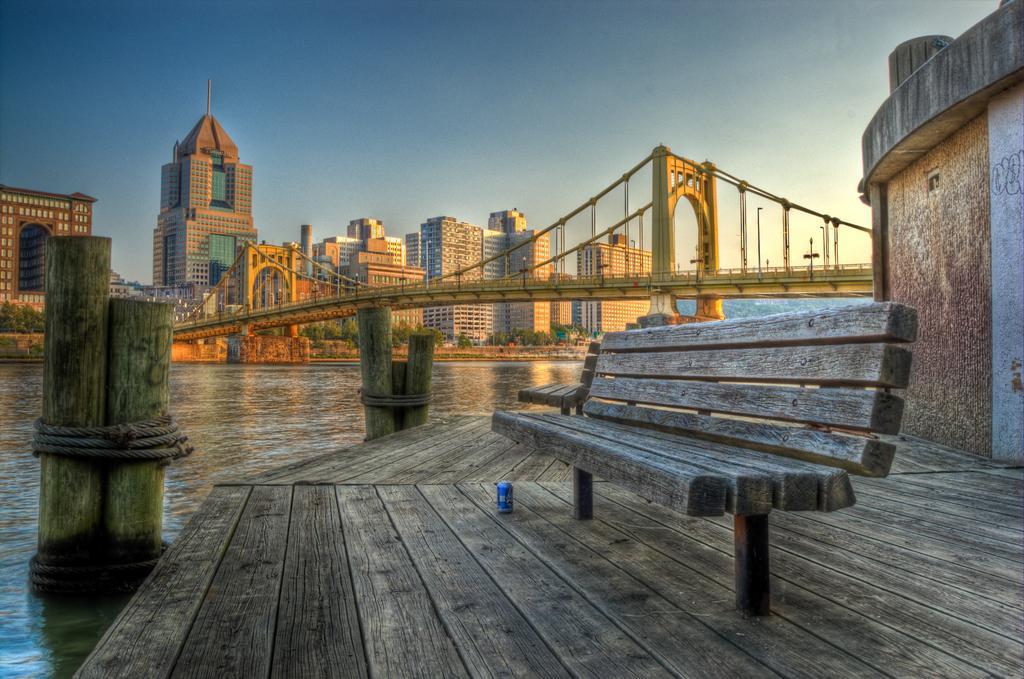Could you give a brief overview of what you see in this image? This is the picture of the city. At the top there is a sky, at the back there are buildings and trees, at the left there is a water and at the front there is a bench, at the bottom there is a tin. 